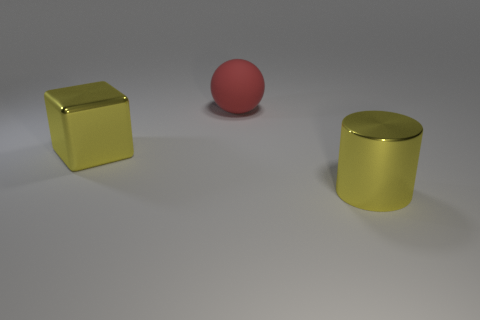Add 3 large rubber things. How many objects exist? 6 Subtract all tiny brown metallic spheres. Subtract all large spheres. How many objects are left? 2 Add 2 large red spheres. How many large red spheres are left? 3 Add 3 big yellow objects. How many big yellow objects exist? 5 Subtract 1 red spheres. How many objects are left? 2 Subtract all cylinders. How many objects are left? 2 